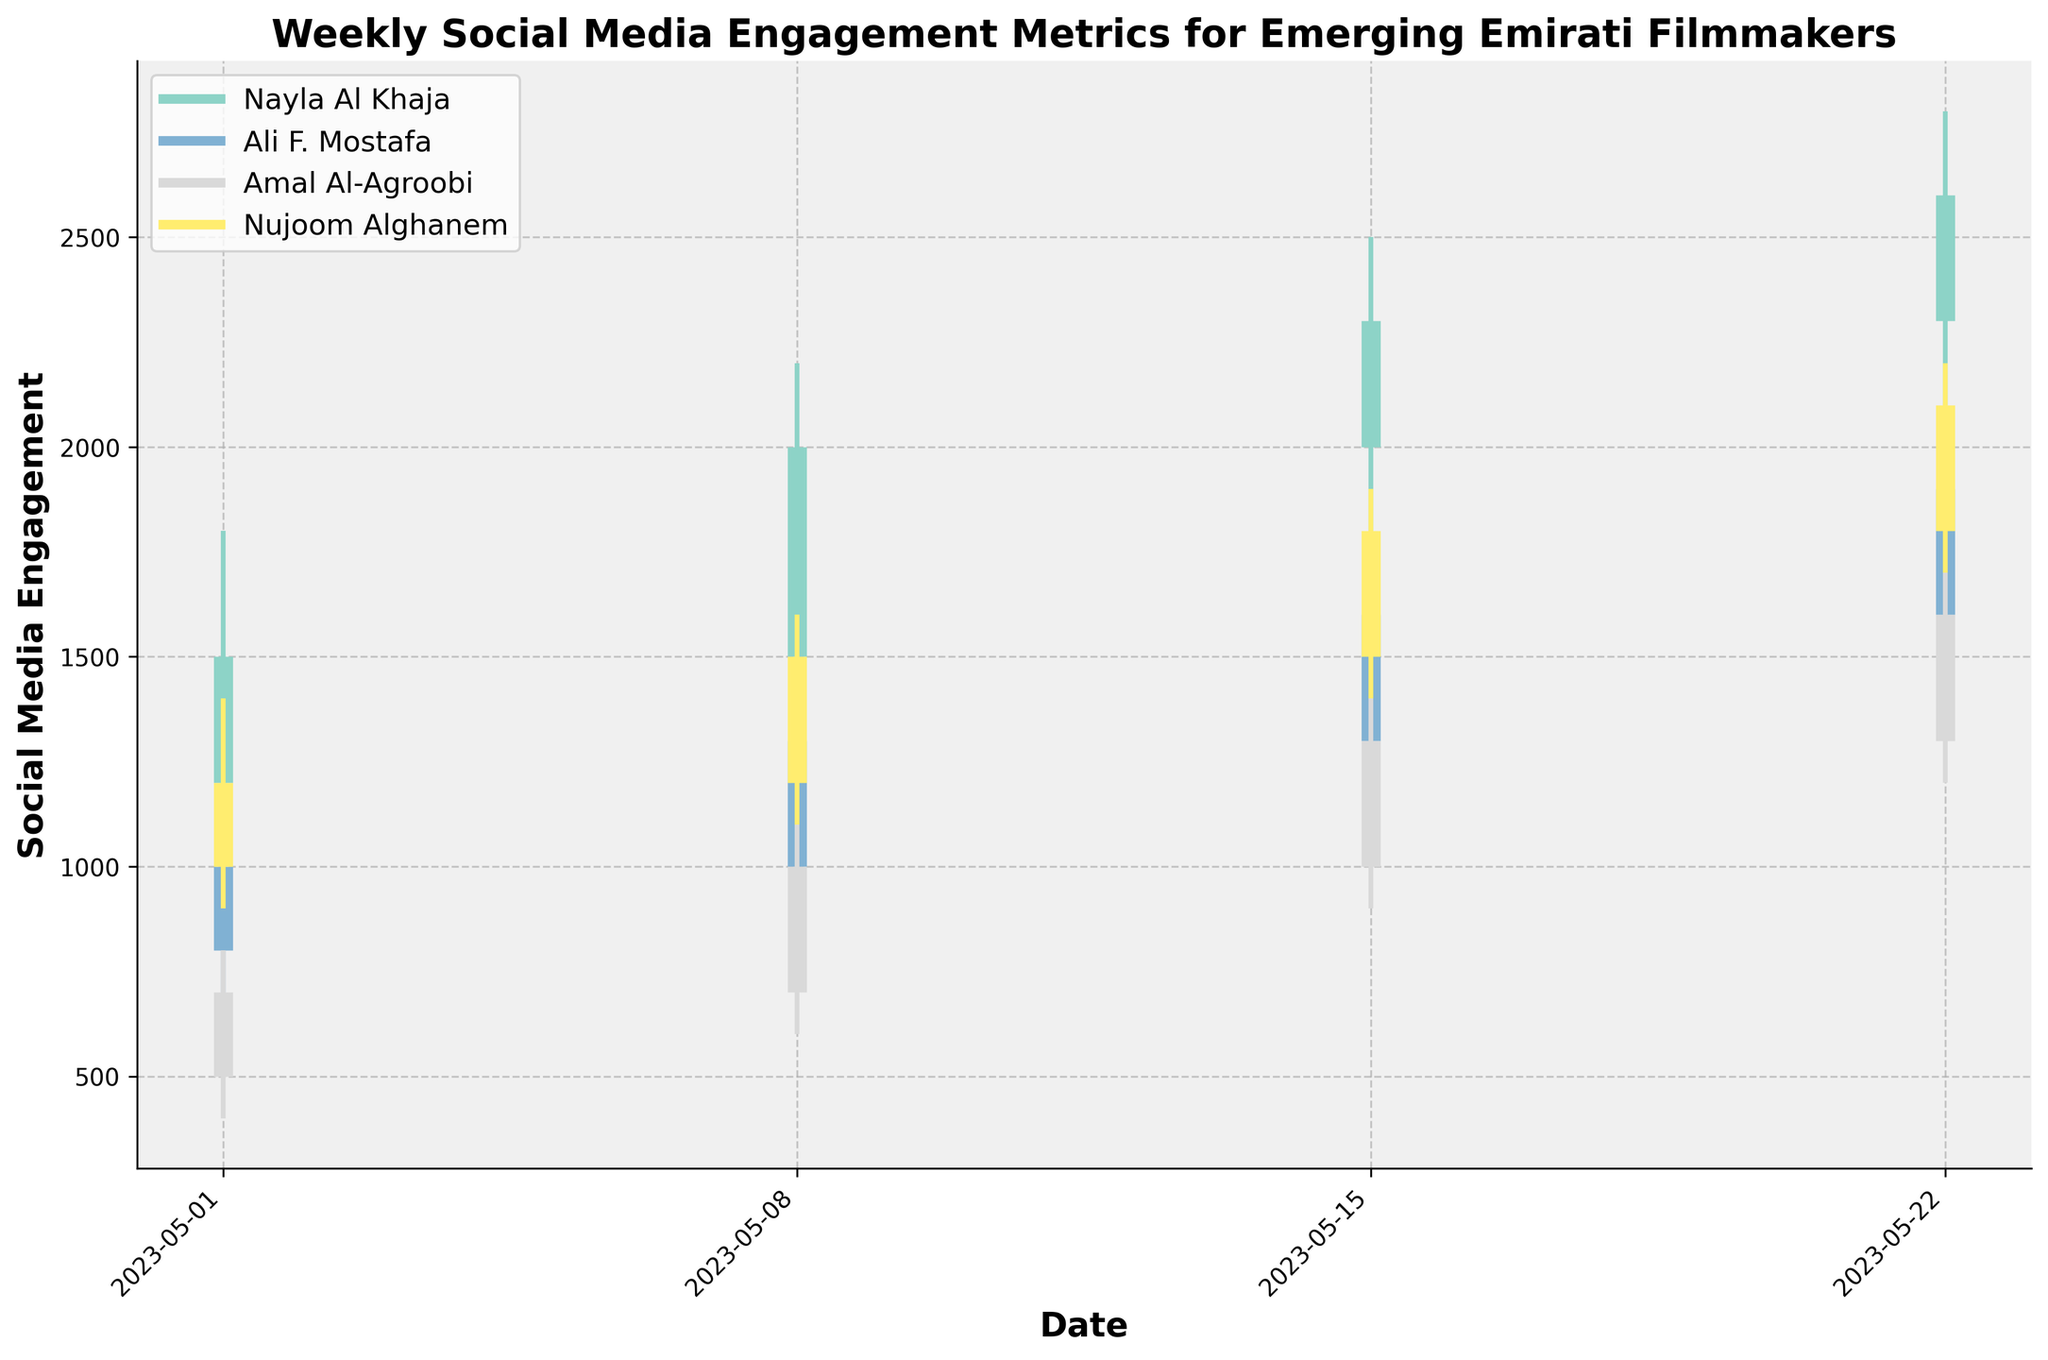What's the title of the figure? The title is displayed at the top of the figure.
Answer: Weekly Social Media Engagement Metrics for Emerging Emirati Filmmakers What are the axis labels of the figure? The labels for the x-axis and y-axis are typically shown along the axes. The x-axis label is at the bottom and the y-axis label is on the left side.
Answer: Date (x-axis) and Social Media Engagement (y-axis) How many filmmakers are represented in the figure? The legend lists all the filmmakers shown with corresponding colors. Count the number of different filmmakers in the legend.
Answer: Four Which filmmaker has the highest engagement in the week of May 15, 2023? Look for the data with the highest 'High' value for the week of May 15, 2023.
Answer: Nayla Al Khaja Among the filmmakers shown, which one has the lowest opening engagement on May 1, 2023? Compare the 'Open' values for all filmmakers on May 1, 2023.
Answer: Amal Al-Agroobi What is the overall trend in the social media engagement of Nayla Al Khaja over the weeks shown? Analyze the 'Close' values for Nayla Al Khaja across each week. Her engagement starts at 1500, then increases steadily each week to 2600.
Answer: Increasing Who experienced the widest range of social media engagement on May 22, 2023? The range is determined by the difference between 'High' and 'Low' values. Compare the ranges for all filmmakers on May 22, 2023.
Answer: Nayla Al Khaja Does Nujoom Alghanem's engagement trend follow an increasing or decreasing pattern? Analyze the 'Close' values for Nujoom Alghanem over the weeks.
Answer: Increasing Which filmmaker had the highest engagement (Close value) by the end of the month? Compare the 'Close' values of all filmmakers for the week of May 22, 2023.
Answer: Nayla Al Khaja What is the average opening engagement for Ali F. Mostafa over all weeks shown? Sum all 'Open' values for Ali F. Mostafa across the weeks and then divide by the number of weeks. (800 + 1000 + 1300 + 1600) / 4 = 1175
Answer: 1175 